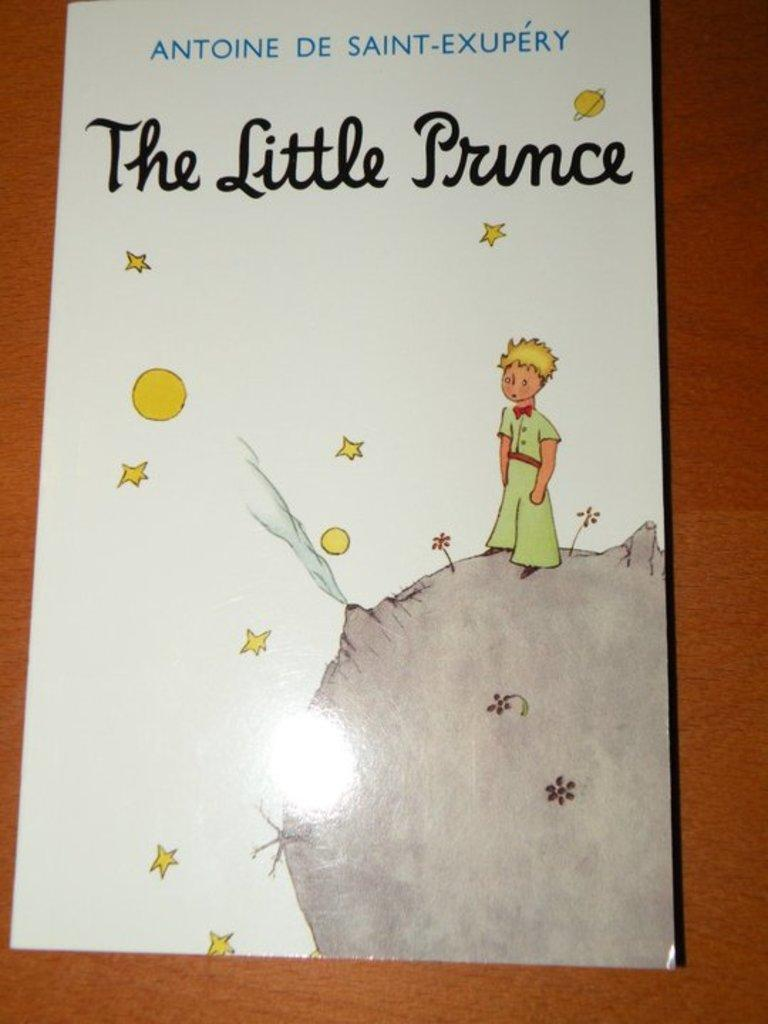<image>
Offer a succinct explanation of the picture presented. The cover of the book "The Little Prince" by Antoine De Saint-Exupery. 